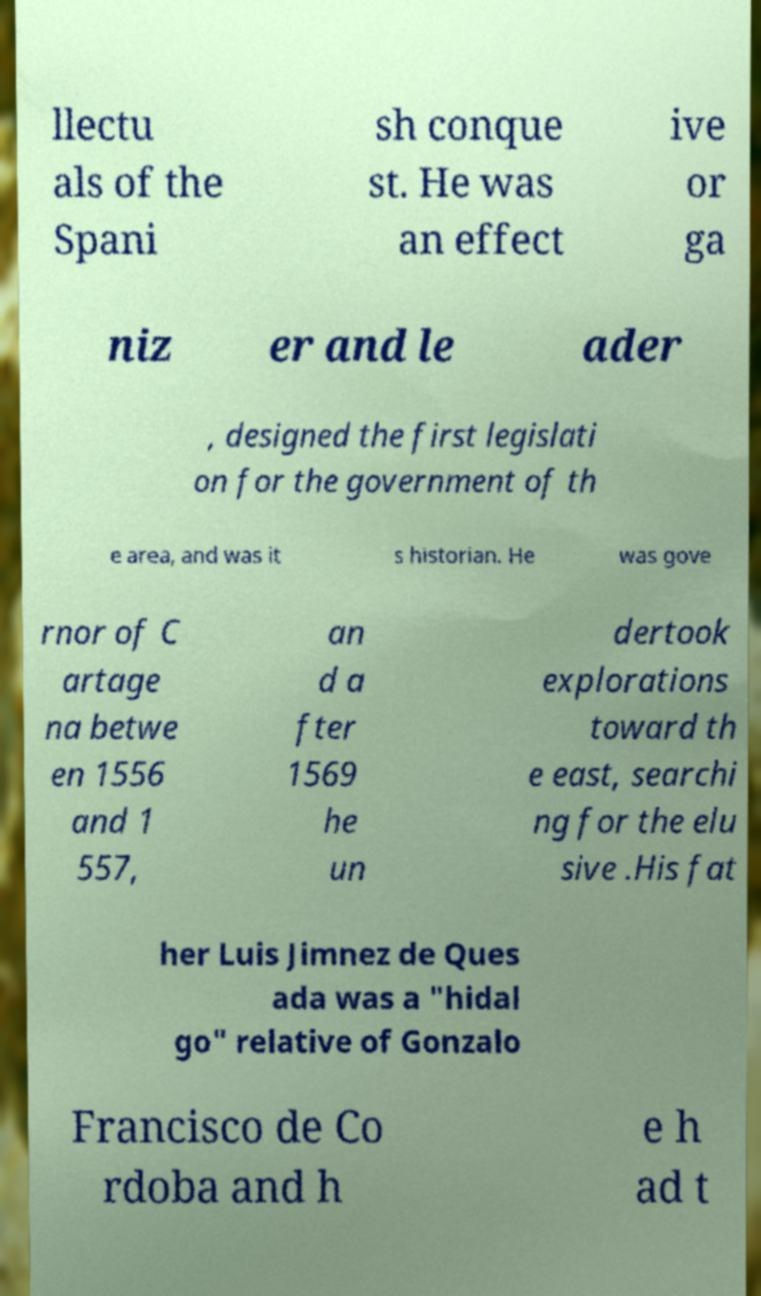Could you assist in decoding the text presented in this image and type it out clearly? llectu als of the Spani sh conque st. He was an effect ive or ga niz er and le ader , designed the first legislati on for the government of th e area, and was it s historian. He was gove rnor of C artage na betwe en 1556 and 1 557, an d a fter 1569 he un dertook explorations toward th e east, searchi ng for the elu sive .His fat her Luis Jimnez de Ques ada was a "hidal go" relative of Gonzalo Francisco de Co rdoba and h e h ad t 